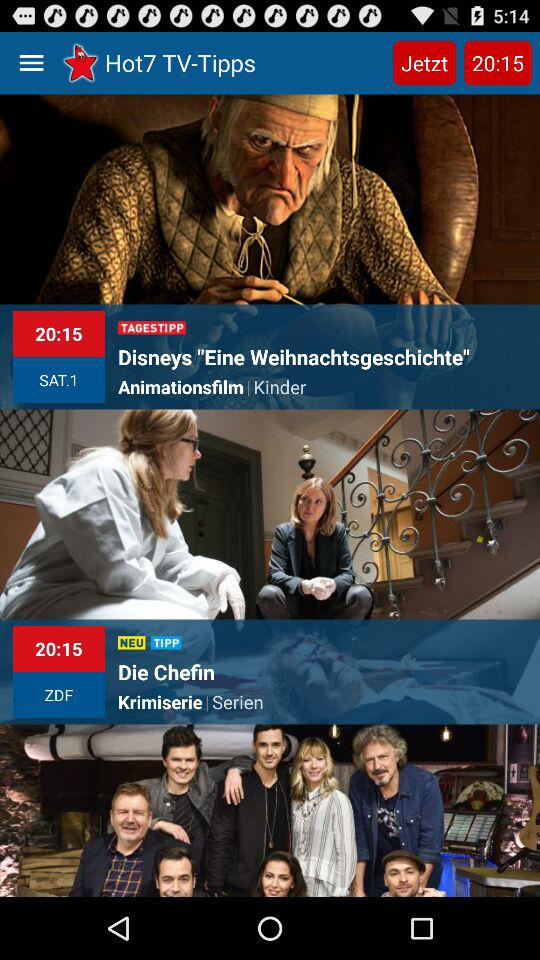What is the name of the application? The name of the application is "Hot7 TV-Tipps". 